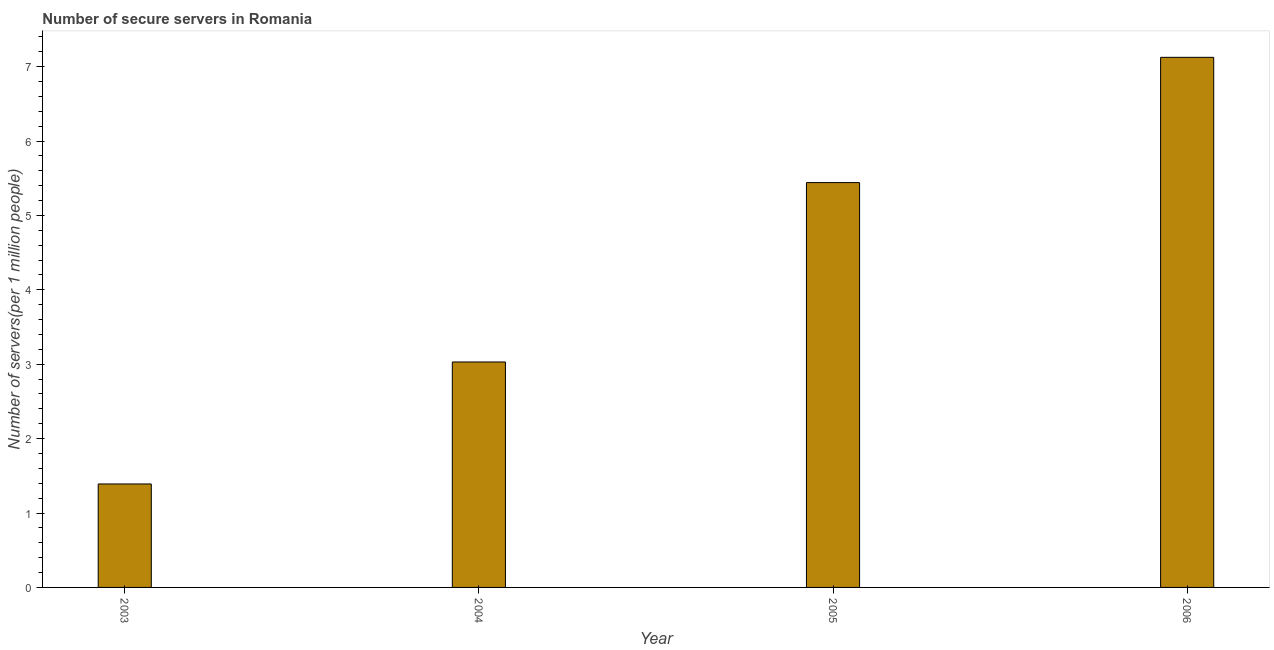Does the graph contain any zero values?
Offer a very short reply. No. Does the graph contain grids?
Your answer should be very brief. No. What is the title of the graph?
Make the answer very short. Number of secure servers in Romania. What is the label or title of the X-axis?
Keep it short and to the point. Year. What is the label or title of the Y-axis?
Give a very brief answer. Number of servers(per 1 million people). What is the number of secure internet servers in 2005?
Offer a terse response. 5.44. Across all years, what is the maximum number of secure internet servers?
Your answer should be compact. 7.12. Across all years, what is the minimum number of secure internet servers?
Your answer should be compact. 1.39. In which year was the number of secure internet servers maximum?
Ensure brevity in your answer.  2006. In which year was the number of secure internet servers minimum?
Your response must be concise. 2003. What is the sum of the number of secure internet servers?
Provide a succinct answer. 16.99. What is the difference between the number of secure internet servers in 2004 and 2006?
Keep it short and to the point. -4.09. What is the average number of secure internet servers per year?
Offer a very short reply. 4.25. What is the median number of secure internet servers?
Your answer should be very brief. 4.24. What is the ratio of the number of secure internet servers in 2005 to that in 2006?
Offer a terse response. 0.76. What is the difference between the highest and the second highest number of secure internet servers?
Keep it short and to the point. 1.68. Is the sum of the number of secure internet servers in 2005 and 2006 greater than the maximum number of secure internet servers across all years?
Give a very brief answer. Yes. What is the difference between the highest and the lowest number of secure internet servers?
Offer a very short reply. 5.73. In how many years, is the number of secure internet servers greater than the average number of secure internet servers taken over all years?
Provide a short and direct response. 2. How many bars are there?
Offer a terse response. 4. Are all the bars in the graph horizontal?
Provide a succinct answer. No. How many years are there in the graph?
Ensure brevity in your answer.  4. Are the values on the major ticks of Y-axis written in scientific E-notation?
Provide a short and direct response. No. What is the Number of servers(per 1 million people) of 2003?
Keep it short and to the point. 1.39. What is the Number of servers(per 1 million people) of 2004?
Your answer should be very brief. 3.03. What is the Number of servers(per 1 million people) of 2005?
Provide a short and direct response. 5.44. What is the Number of servers(per 1 million people) in 2006?
Provide a short and direct response. 7.12. What is the difference between the Number of servers(per 1 million people) in 2003 and 2004?
Your response must be concise. -1.64. What is the difference between the Number of servers(per 1 million people) in 2003 and 2005?
Provide a succinct answer. -4.05. What is the difference between the Number of servers(per 1 million people) in 2003 and 2006?
Keep it short and to the point. -5.73. What is the difference between the Number of servers(per 1 million people) in 2004 and 2005?
Make the answer very short. -2.41. What is the difference between the Number of servers(per 1 million people) in 2004 and 2006?
Provide a short and direct response. -4.09. What is the difference between the Number of servers(per 1 million people) in 2005 and 2006?
Offer a very short reply. -1.68. What is the ratio of the Number of servers(per 1 million people) in 2003 to that in 2004?
Ensure brevity in your answer.  0.46. What is the ratio of the Number of servers(per 1 million people) in 2003 to that in 2005?
Your answer should be compact. 0.26. What is the ratio of the Number of servers(per 1 million people) in 2003 to that in 2006?
Ensure brevity in your answer.  0.2. What is the ratio of the Number of servers(per 1 million people) in 2004 to that in 2005?
Keep it short and to the point. 0.56. What is the ratio of the Number of servers(per 1 million people) in 2004 to that in 2006?
Offer a very short reply. 0.42. What is the ratio of the Number of servers(per 1 million people) in 2005 to that in 2006?
Keep it short and to the point. 0.76. 